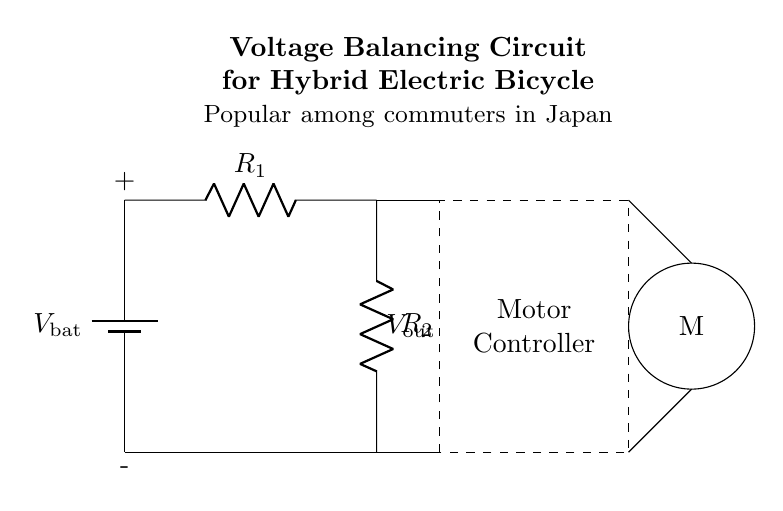What is the type of the circuit shown? The circuit is a voltage balancing circuit, as indicated by the presence of resistors in parallel and the description in the title.
Answer: Voltage balancing circuit What components are present in the circuit? The circuit contains a battery, two resistors, a motor controller, and a motor. These components are visualized in the diagram with specific labels.
Answer: Battery, resistors, motor controller, motor What is the output voltage referred to in the circuit? The output voltage, labeled as V_out, is the voltage between the two points where the resistors connect to the motor controller. This is inferred from the labeled connections.
Answer: V_out How many resistors are in the circuit? There are two resistors shown in the diagram, labeled R_1 and R_2, positioned horizontally and vertically in the circuit configuration.
Answer: Two What is the main function of the resistors in this circuit? The resistors function as a voltage divider, allowing the circuit to distribute the voltage across different components according to their resistance values.
Answer: Voltage divider What happens to the current in the resistors? The current through the circuit divides between the two resistors according to Ohm's law, which states that current is inversely proportional to resistance in parallel configurations.
Answer: Divides What does the dashed rectangle represent in this circuit? The dashed rectangle symbolizes the motor controller, serving as part of the system that manages the power supplied to the motor based on the output voltage.
Answer: Motor controller 